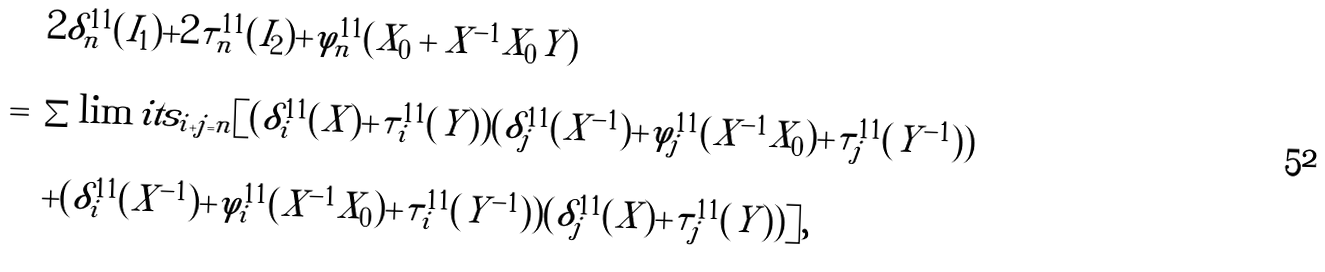Convert formula to latex. <formula><loc_0><loc_0><loc_500><loc_500>\begin{array} { r c l } & & 2 \delta _ { n } ^ { 1 1 } ( I _ { 1 } ) + 2 \tau _ { n } ^ { 1 1 } ( I _ { 2 } ) + \varphi _ { n } ^ { 1 1 } ( X _ { 0 } + X ^ { - 1 } X _ { 0 } Y ) \\ \\ & = & \sum \lim i t s _ { i + j = n } [ ( \delta _ { i } ^ { 1 1 } ( X ) + \tau _ { i } ^ { 1 1 } ( Y ) ) ( \delta _ { j } ^ { 1 1 } ( X ^ { - 1 } ) + \varphi _ { j } ^ { 1 1 } ( X ^ { - 1 } X _ { 0 } ) + \tau _ { j } ^ { 1 1 } ( Y ^ { - 1 } ) ) \\ \\ & & + ( \delta _ { i } ^ { 1 1 } ( X ^ { - 1 } ) + \varphi _ { i } ^ { 1 1 } ( X ^ { - 1 } X _ { 0 } ) + \tau _ { i } ^ { 1 1 } ( Y ^ { - 1 } ) ) ( \delta _ { j } ^ { 1 1 } ( X ) + \tau _ { j } ^ { 1 1 } ( Y ) ) ] , \end{array}</formula> 